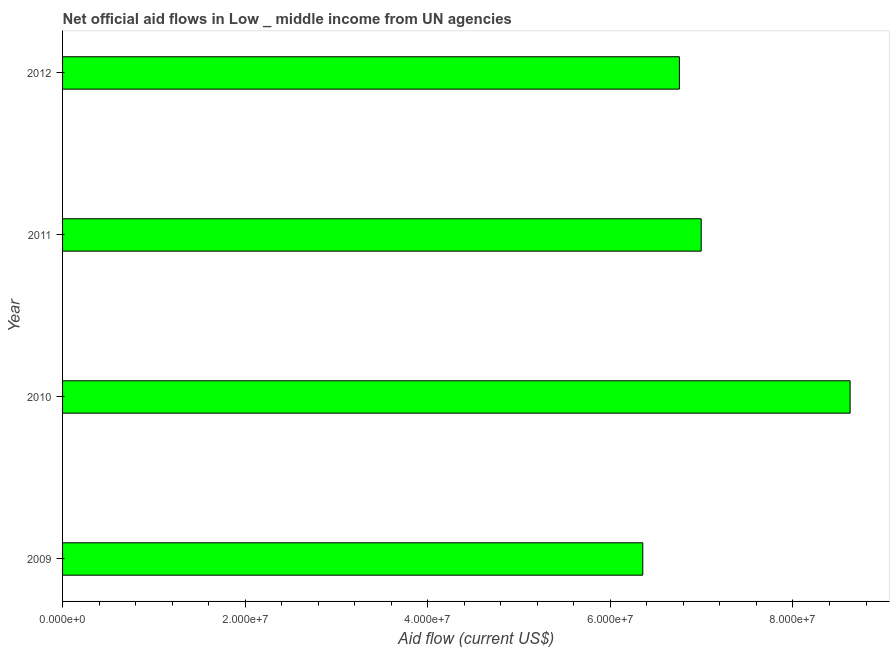Does the graph contain grids?
Your answer should be very brief. No. What is the title of the graph?
Make the answer very short. Net official aid flows in Low _ middle income from UN agencies. What is the label or title of the X-axis?
Make the answer very short. Aid flow (current US$). What is the label or title of the Y-axis?
Give a very brief answer. Year. What is the net official flows from un agencies in 2012?
Your answer should be very brief. 6.76e+07. Across all years, what is the maximum net official flows from un agencies?
Ensure brevity in your answer.  8.63e+07. Across all years, what is the minimum net official flows from un agencies?
Provide a succinct answer. 6.36e+07. In which year was the net official flows from un agencies minimum?
Keep it short and to the point. 2009. What is the sum of the net official flows from un agencies?
Provide a succinct answer. 2.87e+08. What is the difference between the net official flows from un agencies in 2009 and 2011?
Offer a terse response. -6.40e+06. What is the average net official flows from un agencies per year?
Offer a very short reply. 7.18e+07. What is the median net official flows from un agencies?
Offer a very short reply. 6.88e+07. In how many years, is the net official flows from un agencies greater than 32000000 US$?
Keep it short and to the point. 4. Do a majority of the years between 2011 and 2010 (inclusive) have net official flows from un agencies greater than 68000000 US$?
Offer a very short reply. No. What is the ratio of the net official flows from un agencies in 2010 to that in 2011?
Keep it short and to the point. 1.23. Is the net official flows from un agencies in 2010 less than that in 2012?
Offer a terse response. No. What is the difference between the highest and the second highest net official flows from un agencies?
Your answer should be very brief. 1.63e+07. Is the sum of the net official flows from un agencies in 2009 and 2011 greater than the maximum net official flows from un agencies across all years?
Your answer should be very brief. Yes. What is the difference between the highest and the lowest net official flows from un agencies?
Provide a short and direct response. 2.27e+07. How many bars are there?
Ensure brevity in your answer.  4. Are the values on the major ticks of X-axis written in scientific E-notation?
Provide a succinct answer. Yes. What is the Aid flow (current US$) of 2009?
Keep it short and to the point. 6.36e+07. What is the Aid flow (current US$) in 2010?
Your answer should be very brief. 8.63e+07. What is the Aid flow (current US$) of 2011?
Keep it short and to the point. 7.00e+07. What is the Aid flow (current US$) in 2012?
Provide a short and direct response. 6.76e+07. What is the difference between the Aid flow (current US$) in 2009 and 2010?
Provide a short and direct response. -2.27e+07. What is the difference between the Aid flow (current US$) in 2009 and 2011?
Make the answer very short. -6.40e+06. What is the difference between the Aid flow (current US$) in 2009 and 2012?
Provide a short and direct response. -4.01e+06. What is the difference between the Aid flow (current US$) in 2010 and 2011?
Your answer should be very brief. 1.63e+07. What is the difference between the Aid flow (current US$) in 2010 and 2012?
Your answer should be compact. 1.87e+07. What is the difference between the Aid flow (current US$) in 2011 and 2012?
Your response must be concise. 2.39e+06. What is the ratio of the Aid flow (current US$) in 2009 to that in 2010?
Make the answer very short. 0.74. What is the ratio of the Aid flow (current US$) in 2009 to that in 2011?
Offer a terse response. 0.91. What is the ratio of the Aid flow (current US$) in 2009 to that in 2012?
Ensure brevity in your answer.  0.94. What is the ratio of the Aid flow (current US$) in 2010 to that in 2011?
Offer a terse response. 1.23. What is the ratio of the Aid flow (current US$) in 2010 to that in 2012?
Make the answer very short. 1.28. What is the ratio of the Aid flow (current US$) in 2011 to that in 2012?
Your answer should be very brief. 1.03. 